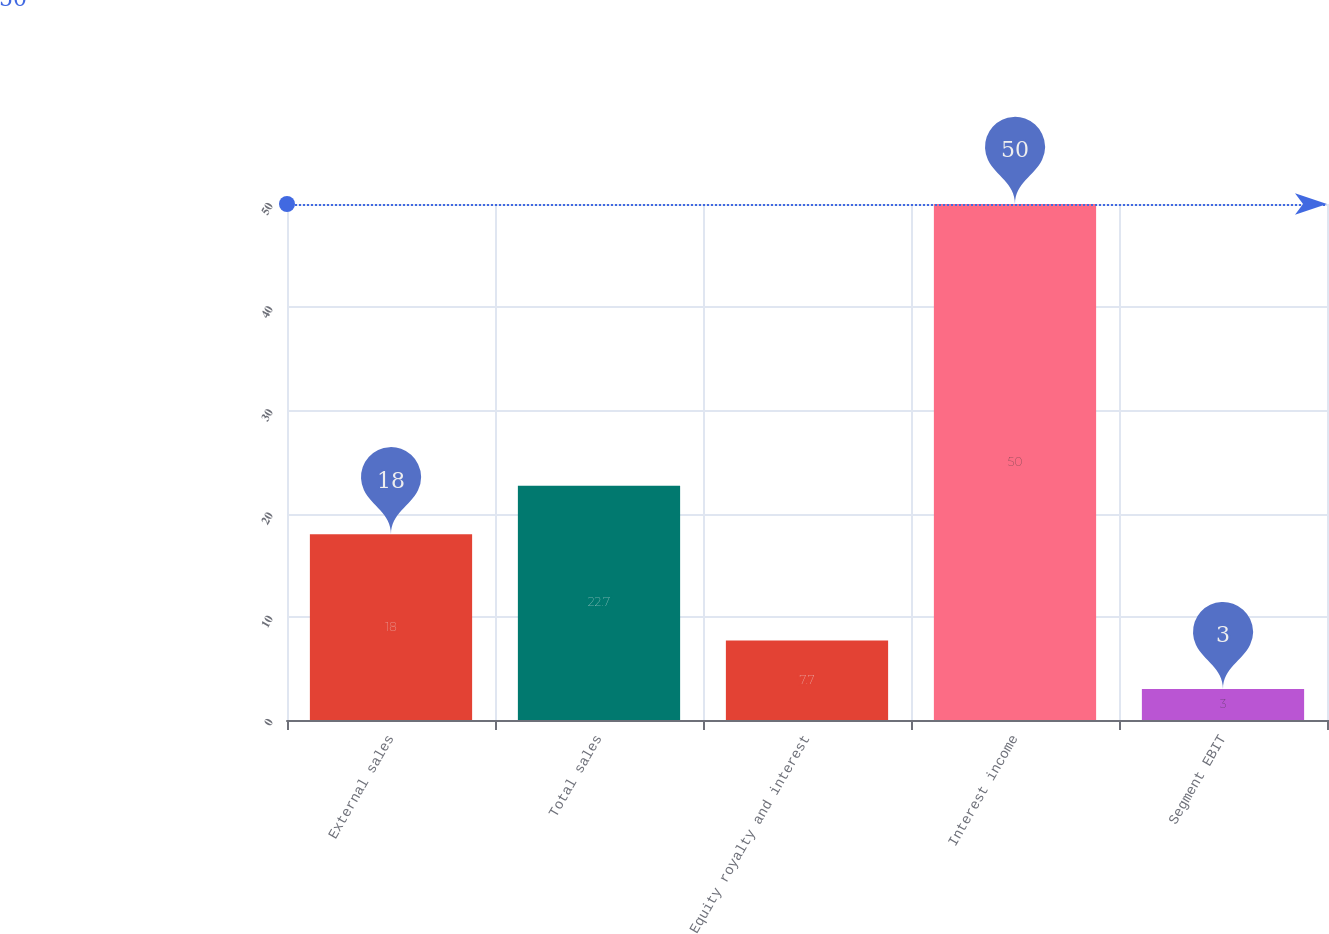Convert chart. <chart><loc_0><loc_0><loc_500><loc_500><bar_chart><fcel>External sales<fcel>Total sales<fcel>Equity royalty and interest<fcel>Interest income<fcel>Segment EBIT<nl><fcel>18<fcel>22.7<fcel>7.7<fcel>50<fcel>3<nl></chart> 